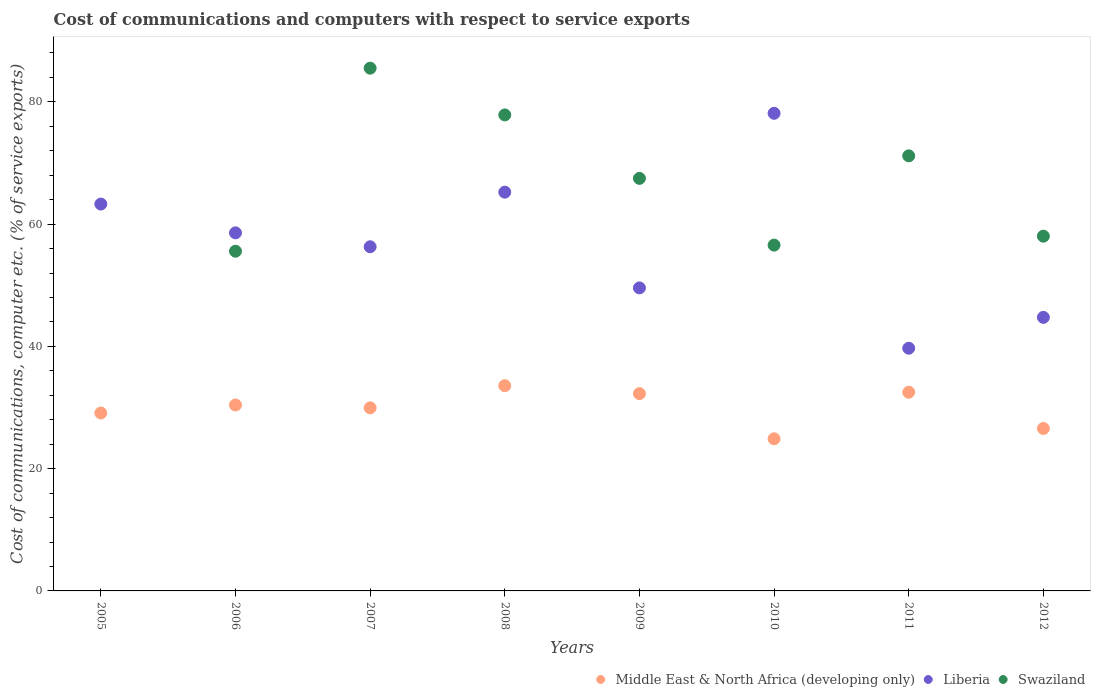How many different coloured dotlines are there?
Offer a terse response. 3. What is the cost of communications and computers in Liberia in 2012?
Offer a very short reply. 44.75. Across all years, what is the maximum cost of communications and computers in Liberia?
Give a very brief answer. 78.13. Across all years, what is the minimum cost of communications and computers in Swaziland?
Offer a very short reply. 0. What is the total cost of communications and computers in Middle East & North Africa (developing only) in the graph?
Provide a short and direct response. 239.25. What is the difference between the cost of communications and computers in Liberia in 2008 and that in 2012?
Provide a succinct answer. 20.48. What is the difference between the cost of communications and computers in Middle East & North Africa (developing only) in 2006 and the cost of communications and computers in Liberia in 2010?
Offer a terse response. -47.72. What is the average cost of communications and computers in Middle East & North Africa (developing only) per year?
Provide a short and direct response. 29.91. In the year 2009, what is the difference between the cost of communications and computers in Middle East & North Africa (developing only) and cost of communications and computers in Liberia?
Provide a short and direct response. -17.3. What is the ratio of the cost of communications and computers in Swaziland in 2008 to that in 2012?
Give a very brief answer. 1.34. Is the difference between the cost of communications and computers in Middle East & North Africa (developing only) in 2005 and 2011 greater than the difference between the cost of communications and computers in Liberia in 2005 and 2011?
Provide a short and direct response. No. What is the difference between the highest and the second highest cost of communications and computers in Middle East & North Africa (developing only)?
Your answer should be compact. 1.07. What is the difference between the highest and the lowest cost of communications and computers in Middle East & North Africa (developing only)?
Your answer should be compact. 8.69. Is it the case that in every year, the sum of the cost of communications and computers in Swaziland and cost of communications and computers in Middle East & North Africa (developing only)  is greater than the cost of communications and computers in Liberia?
Your answer should be very brief. No. Does the cost of communications and computers in Liberia monotonically increase over the years?
Give a very brief answer. No. Is the cost of communications and computers in Swaziland strictly less than the cost of communications and computers in Liberia over the years?
Keep it short and to the point. No. How many dotlines are there?
Make the answer very short. 3. How many years are there in the graph?
Offer a terse response. 8. What is the difference between two consecutive major ticks on the Y-axis?
Your response must be concise. 20. Where does the legend appear in the graph?
Provide a short and direct response. Bottom right. How many legend labels are there?
Make the answer very short. 3. How are the legend labels stacked?
Your response must be concise. Horizontal. What is the title of the graph?
Offer a very short reply. Cost of communications and computers with respect to service exports. Does "Bosnia and Herzegovina" appear as one of the legend labels in the graph?
Provide a succinct answer. No. What is the label or title of the Y-axis?
Give a very brief answer. Cost of communications, computer etc. (% of service exports). What is the Cost of communications, computer etc. (% of service exports) in Middle East & North Africa (developing only) in 2005?
Make the answer very short. 29.1. What is the Cost of communications, computer etc. (% of service exports) of Liberia in 2005?
Keep it short and to the point. 63.28. What is the Cost of communications, computer etc. (% of service exports) of Middle East & North Africa (developing only) in 2006?
Ensure brevity in your answer.  30.41. What is the Cost of communications, computer etc. (% of service exports) of Liberia in 2006?
Offer a terse response. 58.57. What is the Cost of communications, computer etc. (% of service exports) in Swaziland in 2006?
Make the answer very short. 55.57. What is the Cost of communications, computer etc. (% of service exports) in Middle East & North Africa (developing only) in 2007?
Offer a very short reply. 29.94. What is the Cost of communications, computer etc. (% of service exports) in Liberia in 2007?
Provide a succinct answer. 56.29. What is the Cost of communications, computer etc. (% of service exports) in Swaziland in 2007?
Offer a terse response. 85.51. What is the Cost of communications, computer etc. (% of service exports) in Middle East & North Africa (developing only) in 2008?
Ensure brevity in your answer.  33.57. What is the Cost of communications, computer etc. (% of service exports) in Liberia in 2008?
Ensure brevity in your answer.  65.23. What is the Cost of communications, computer etc. (% of service exports) of Swaziland in 2008?
Keep it short and to the point. 77.86. What is the Cost of communications, computer etc. (% of service exports) in Middle East & North Africa (developing only) in 2009?
Provide a succinct answer. 32.27. What is the Cost of communications, computer etc. (% of service exports) in Liberia in 2009?
Provide a succinct answer. 49.57. What is the Cost of communications, computer etc. (% of service exports) in Swaziland in 2009?
Your response must be concise. 67.48. What is the Cost of communications, computer etc. (% of service exports) of Middle East & North Africa (developing only) in 2010?
Offer a very short reply. 24.88. What is the Cost of communications, computer etc. (% of service exports) in Liberia in 2010?
Ensure brevity in your answer.  78.13. What is the Cost of communications, computer etc. (% of service exports) of Swaziland in 2010?
Give a very brief answer. 56.56. What is the Cost of communications, computer etc. (% of service exports) in Middle East & North Africa (developing only) in 2011?
Your answer should be very brief. 32.5. What is the Cost of communications, computer etc. (% of service exports) of Liberia in 2011?
Keep it short and to the point. 39.7. What is the Cost of communications, computer etc. (% of service exports) in Swaziland in 2011?
Provide a succinct answer. 71.17. What is the Cost of communications, computer etc. (% of service exports) in Middle East & North Africa (developing only) in 2012?
Your answer should be very brief. 26.57. What is the Cost of communications, computer etc. (% of service exports) in Liberia in 2012?
Provide a short and direct response. 44.75. What is the Cost of communications, computer etc. (% of service exports) of Swaziland in 2012?
Give a very brief answer. 58.03. Across all years, what is the maximum Cost of communications, computer etc. (% of service exports) of Middle East & North Africa (developing only)?
Provide a succinct answer. 33.57. Across all years, what is the maximum Cost of communications, computer etc. (% of service exports) of Liberia?
Offer a terse response. 78.13. Across all years, what is the maximum Cost of communications, computer etc. (% of service exports) in Swaziland?
Give a very brief answer. 85.51. Across all years, what is the minimum Cost of communications, computer etc. (% of service exports) in Middle East & North Africa (developing only)?
Offer a very short reply. 24.88. Across all years, what is the minimum Cost of communications, computer etc. (% of service exports) in Liberia?
Your response must be concise. 39.7. What is the total Cost of communications, computer etc. (% of service exports) in Middle East & North Africa (developing only) in the graph?
Make the answer very short. 239.25. What is the total Cost of communications, computer etc. (% of service exports) in Liberia in the graph?
Offer a terse response. 455.51. What is the total Cost of communications, computer etc. (% of service exports) of Swaziland in the graph?
Your answer should be compact. 472.18. What is the difference between the Cost of communications, computer etc. (% of service exports) of Middle East & North Africa (developing only) in 2005 and that in 2006?
Your answer should be very brief. -1.31. What is the difference between the Cost of communications, computer etc. (% of service exports) in Liberia in 2005 and that in 2006?
Offer a terse response. 4.71. What is the difference between the Cost of communications, computer etc. (% of service exports) of Middle East & North Africa (developing only) in 2005 and that in 2007?
Give a very brief answer. -0.84. What is the difference between the Cost of communications, computer etc. (% of service exports) in Liberia in 2005 and that in 2007?
Keep it short and to the point. 6.99. What is the difference between the Cost of communications, computer etc. (% of service exports) in Middle East & North Africa (developing only) in 2005 and that in 2008?
Make the answer very short. -4.47. What is the difference between the Cost of communications, computer etc. (% of service exports) in Liberia in 2005 and that in 2008?
Offer a terse response. -1.94. What is the difference between the Cost of communications, computer etc. (% of service exports) of Middle East & North Africa (developing only) in 2005 and that in 2009?
Make the answer very short. -3.17. What is the difference between the Cost of communications, computer etc. (% of service exports) in Liberia in 2005 and that in 2009?
Offer a very short reply. 13.71. What is the difference between the Cost of communications, computer etc. (% of service exports) in Middle East & North Africa (developing only) in 2005 and that in 2010?
Provide a succinct answer. 4.22. What is the difference between the Cost of communications, computer etc. (% of service exports) in Liberia in 2005 and that in 2010?
Provide a short and direct response. -14.84. What is the difference between the Cost of communications, computer etc. (% of service exports) in Middle East & North Africa (developing only) in 2005 and that in 2011?
Offer a terse response. -3.4. What is the difference between the Cost of communications, computer etc. (% of service exports) of Liberia in 2005 and that in 2011?
Provide a short and direct response. 23.58. What is the difference between the Cost of communications, computer etc. (% of service exports) of Middle East & North Africa (developing only) in 2005 and that in 2012?
Ensure brevity in your answer.  2.53. What is the difference between the Cost of communications, computer etc. (% of service exports) in Liberia in 2005 and that in 2012?
Make the answer very short. 18.53. What is the difference between the Cost of communications, computer etc. (% of service exports) of Middle East & North Africa (developing only) in 2006 and that in 2007?
Your answer should be compact. 0.47. What is the difference between the Cost of communications, computer etc. (% of service exports) in Liberia in 2006 and that in 2007?
Provide a succinct answer. 2.28. What is the difference between the Cost of communications, computer etc. (% of service exports) of Swaziland in 2006 and that in 2007?
Make the answer very short. -29.94. What is the difference between the Cost of communications, computer etc. (% of service exports) of Middle East & North Africa (developing only) in 2006 and that in 2008?
Your response must be concise. -3.16. What is the difference between the Cost of communications, computer etc. (% of service exports) of Liberia in 2006 and that in 2008?
Give a very brief answer. -6.66. What is the difference between the Cost of communications, computer etc. (% of service exports) in Swaziland in 2006 and that in 2008?
Keep it short and to the point. -22.29. What is the difference between the Cost of communications, computer etc. (% of service exports) of Middle East & North Africa (developing only) in 2006 and that in 2009?
Provide a short and direct response. -1.86. What is the difference between the Cost of communications, computer etc. (% of service exports) of Liberia in 2006 and that in 2009?
Keep it short and to the point. 9. What is the difference between the Cost of communications, computer etc. (% of service exports) in Swaziland in 2006 and that in 2009?
Give a very brief answer. -11.91. What is the difference between the Cost of communications, computer etc. (% of service exports) of Middle East & North Africa (developing only) in 2006 and that in 2010?
Make the answer very short. 5.53. What is the difference between the Cost of communications, computer etc. (% of service exports) in Liberia in 2006 and that in 2010?
Offer a very short reply. -19.56. What is the difference between the Cost of communications, computer etc. (% of service exports) of Swaziland in 2006 and that in 2010?
Your answer should be compact. -0.99. What is the difference between the Cost of communications, computer etc. (% of service exports) of Middle East & North Africa (developing only) in 2006 and that in 2011?
Make the answer very short. -2.09. What is the difference between the Cost of communications, computer etc. (% of service exports) in Liberia in 2006 and that in 2011?
Your response must be concise. 18.87. What is the difference between the Cost of communications, computer etc. (% of service exports) in Swaziland in 2006 and that in 2011?
Keep it short and to the point. -15.6. What is the difference between the Cost of communications, computer etc. (% of service exports) of Middle East & North Africa (developing only) in 2006 and that in 2012?
Your answer should be compact. 3.84. What is the difference between the Cost of communications, computer etc. (% of service exports) in Liberia in 2006 and that in 2012?
Your answer should be very brief. 13.82. What is the difference between the Cost of communications, computer etc. (% of service exports) of Swaziland in 2006 and that in 2012?
Make the answer very short. -2.46. What is the difference between the Cost of communications, computer etc. (% of service exports) of Middle East & North Africa (developing only) in 2007 and that in 2008?
Provide a succinct answer. -3.63. What is the difference between the Cost of communications, computer etc. (% of service exports) in Liberia in 2007 and that in 2008?
Ensure brevity in your answer.  -8.93. What is the difference between the Cost of communications, computer etc. (% of service exports) in Swaziland in 2007 and that in 2008?
Your answer should be very brief. 7.65. What is the difference between the Cost of communications, computer etc. (% of service exports) of Middle East & North Africa (developing only) in 2007 and that in 2009?
Ensure brevity in your answer.  -2.33. What is the difference between the Cost of communications, computer etc. (% of service exports) of Liberia in 2007 and that in 2009?
Your answer should be compact. 6.73. What is the difference between the Cost of communications, computer etc. (% of service exports) of Swaziland in 2007 and that in 2009?
Ensure brevity in your answer.  18.03. What is the difference between the Cost of communications, computer etc. (% of service exports) in Middle East & North Africa (developing only) in 2007 and that in 2010?
Ensure brevity in your answer.  5.06. What is the difference between the Cost of communications, computer etc. (% of service exports) of Liberia in 2007 and that in 2010?
Make the answer very short. -21.83. What is the difference between the Cost of communications, computer etc. (% of service exports) in Swaziland in 2007 and that in 2010?
Make the answer very short. 28.94. What is the difference between the Cost of communications, computer etc. (% of service exports) in Middle East & North Africa (developing only) in 2007 and that in 2011?
Provide a succinct answer. -2.56. What is the difference between the Cost of communications, computer etc. (% of service exports) of Liberia in 2007 and that in 2011?
Make the answer very short. 16.59. What is the difference between the Cost of communications, computer etc. (% of service exports) in Swaziland in 2007 and that in 2011?
Provide a short and direct response. 14.34. What is the difference between the Cost of communications, computer etc. (% of service exports) in Middle East & North Africa (developing only) in 2007 and that in 2012?
Provide a short and direct response. 3.37. What is the difference between the Cost of communications, computer etc. (% of service exports) of Liberia in 2007 and that in 2012?
Offer a very short reply. 11.55. What is the difference between the Cost of communications, computer etc. (% of service exports) in Swaziland in 2007 and that in 2012?
Keep it short and to the point. 27.48. What is the difference between the Cost of communications, computer etc. (% of service exports) in Liberia in 2008 and that in 2009?
Keep it short and to the point. 15.66. What is the difference between the Cost of communications, computer etc. (% of service exports) of Swaziland in 2008 and that in 2009?
Offer a very short reply. 10.38. What is the difference between the Cost of communications, computer etc. (% of service exports) of Middle East & North Africa (developing only) in 2008 and that in 2010?
Ensure brevity in your answer.  8.69. What is the difference between the Cost of communications, computer etc. (% of service exports) of Liberia in 2008 and that in 2010?
Give a very brief answer. -12.9. What is the difference between the Cost of communications, computer etc. (% of service exports) in Swaziland in 2008 and that in 2010?
Ensure brevity in your answer.  21.3. What is the difference between the Cost of communications, computer etc. (% of service exports) of Middle East & North Africa (developing only) in 2008 and that in 2011?
Make the answer very short. 1.07. What is the difference between the Cost of communications, computer etc. (% of service exports) of Liberia in 2008 and that in 2011?
Your answer should be compact. 25.53. What is the difference between the Cost of communications, computer etc. (% of service exports) in Swaziland in 2008 and that in 2011?
Make the answer very short. 6.69. What is the difference between the Cost of communications, computer etc. (% of service exports) of Middle East & North Africa (developing only) in 2008 and that in 2012?
Provide a succinct answer. 7. What is the difference between the Cost of communications, computer etc. (% of service exports) of Liberia in 2008 and that in 2012?
Offer a terse response. 20.48. What is the difference between the Cost of communications, computer etc. (% of service exports) of Swaziland in 2008 and that in 2012?
Offer a terse response. 19.83. What is the difference between the Cost of communications, computer etc. (% of service exports) in Middle East & North Africa (developing only) in 2009 and that in 2010?
Make the answer very short. 7.39. What is the difference between the Cost of communications, computer etc. (% of service exports) in Liberia in 2009 and that in 2010?
Your answer should be compact. -28.56. What is the difference between the Cost of communications, computer etc. (% of service exports) in Swaziland in 2009 and that in 2010?
Provide a short and direct response. 10.92. What is the difference between the Cost of communications, computer etc. (% of service exports) in Middle East & North Africa (developing only) in 2009 and that in 2011?
Your answer should be compact. -0.23. What is the difference between the Cost of communications, computer etc. (% of service exports) of Liberia in 2009 and that in 2011?
Keep it short and to the point. 9.87. What is the difference between the Cost of communications, computer etc. (% of service exports) of Swaziland in 2009 and that in 2011?
Give a very brief answer. -3.68. What is the difference between the Cost of communications, computer etc. (% of service exports) of Middle East & North Africa (developing only) in 2009 and that in 2012?
Give a very brief answer. 5.7. What is the difference between the Cost of communications, computer etc. (% of service exports) in Liberia in 2009 and that in 2012?
Give a very brief answer. 4.82. What is the difference between the Cost of communications, computer etc. (% of service exports) of Swaziland in 2009 and that in 2012?
Your answer should be very brief. 9.46. What is the difference between the Cost of communications, computer etc. (% of service exports) in Middle East & North Africa (developing only) in 2010 and that in 2011?
Your answer should be compact. -7.62. What is the difference between the Cost of communications, computer etc. (% of service exports) of Liberia in 2010 and that in 2011?
Provide a succinct answer. 38.43. What is the difference between the Cost of communications, computer etc. (% of service exports) in Swaziland in 2010 and that in 2011?
Provide a short and direct response. -14.6. What is the difference between the Cost of communications, computer etc. (% of service exports) in Middle East & North Africa (developing only) in 2010 and that in 2012?
Your response must be concise. -1.69. What is the difference between the Cost of communications, computer etc. (% of service exports) of Liberia in 2010 and that in 2012?
Give a very brief answer. 33.38. What is the difference between the Cost of communications, computer etc. (% of service exports) of Swaziland in 2010 and that in 2012?
Give a very brief answer. -1.46. What is the difference between the Cost of communications, computer etc. (% of service exports) of Middle East & North Africa (developing only) in 2011 and that in 2012?
Your answer should be very brief. 5.93. What is the difference between the Cost of communications, computer etc. (% of service exports) in Liberia in 2011 and that in 2012?
Give a very brief answer. -5.05. What is the difference between the Cost of communications, computer etc. (% of service exports) of Swaziland in 2011 and that in 2012?
Give a very brief answer. 13.14. What is the difference between the Cost of communications, computer etc. (% of service exports) in Middle East & North Africa (developing only) in 2005 and the Cost of communications, computer etc. (% of service exports) in Liberia in 2006?
Make the answer very short. -29.47. What is the difference between the Cost of communications, computer etc. (% of service exports) of Middle East & North Africa (developing only) in 2005 and the Cost of communications, computer etc. (% of service exports) of Swaziland in 2006?
Offer a very short reply. -26.47. What is the difference between the Cost of communications, computer etc. (% of service exports) of Liberia in 2005 and the Cost of communications, computer etc. (% of service exports) of Swaziland in 2006?
Make the answer very short. 7.71. What is the difference between the Cost of communications, computer etc. (% of service exports) in Middle East & North Africa (developing only) in 2005 and the Cost of communications, computer etc. (% of service exports) in Liberia in 2007?
Provide a short and direct response. -27.19. What is the difference between the Cost of communications, computer etc. (% of service exports) of Middle East & North Africa (developing only) in 2005 and the Cost of communications, computer etc. (% of service exports) of Swaziland in 2007?
Offer a terse response. -56.41. What is the difference between the Cost of communications, computer etc. (% of service exports) in Liberia in 2005 and the Cost of communications, computer etc. (% of service exports) in Swaziland in 2007?
Offer a very short reply. -22.23. What is the difference between the Cost of communications, computer etc. (% of service exports) of Middle East & North Africa (developing only) in 2005 and the Cost of communications, computer etc. (% of service exports) of Liberia in 2008?
Your answer should be very brief. -36.12. What is the difference between the Cost of communications, computer etc. (% of service exports) in Middle East & North Africa (developing only) in 2005 and the Cost of communications, computer etc. (% of service exports) in Swaziland in 2008?
Provide a succinct answer. -48.76. What is the difference between the Cost of communications, computer etc. (% of service exports) of Liberia in 2005 and the Cost of communications, computer etc. (% of service exports) of Swaziland in 2008?
Your answer should be very brief. -14.58. What is the difference between the Cost of communications, computer etc. (% of service exports) in Middle East & North Africa (developing only) in 2005 and the Cost of communications, computer etc. (% of service exports) in Liberia in 2009?
Your answer should be compact. -20.47. What is the difference between the Cost of communications, computer etc. (% of service exports) of Middle East & North Africa (developing only) in 2005 and the Cost of communications, computer etc. (% of service exports) of Swaziland in 2009?
Keep it short and to the point. -38.38. What is the difference between the Cost of communications, computer etc. (% of service exports) of Liberia in 2005 and the Cost of communications, computer etc. (% of service exports) of Swaziland in 2009?
Provide a short and direct response. -4.2. What is the difference between the Cost of communications, computer etc. (% of service exports) in Middle East & North Africa (developing only) in 2005 and the Cost of communications, computer etc. (% of service exports) in Liberia in 2010?
Keep it short and to the point. -49.03. What is the difference between the Cost of communications, computer etc. (% of service exports) in Middle East & North Africa (developing only) in 2005 and the Cost of communications, computer etc. (% of service exports) in Swaziland in 2010?
Your response must be concise. -27.46. What is the difference between the Cost of communications, computer etc. (% of service exports) of Liberia in 2005 and the Cost of communications, computer etc. (% of service exports) of Swaziland in 2010?
Give a very brief answer. 6.72. What is the difference between the Cost of communications, computer etc. (% of service exports) of Middle East & North Africa (developing only) in 2005 and the Cost of communications, computer etc. (% of service exports) of Liberia in 2011?
Give a very brief answer. -10.6. What is the difference between the Cost of communications, computer etc. (% of service exports) in Middle East & North Africa (developing only) in 2005 and the Cost of communications, computer etc. (% of service exports) in Swaziland in 2011?
Your answer should be compact. -42.07. What is the difference between the Cost of communications, computer etc. (% of service exports) in Liberia in 2005 and the Cost of communications, computer etc. (% of service exports) in Swaziland in 2011?
Give a very brief answer. -7.89. What is the difference between the Cost of communications, computer etc. (% of service exports) of Middle East & North Africa (developing only) in 2005 and the Cost of communications, computer etc. (% of service exports) of Liberia in 2012?
Provide a succinct answer. -15.65. What is the difference between the Cost of communications, computer etc. (% of service exports) of Middle East & North Africa (developing only) in 2005 and the Cost of communications, computer etc. (% of service exports) of Swaziland in 2012?
Your response must be concise. -28.93. What is the difference between the Cost of communications, computer etc. (% of service exports) in Liberia in 2005 and the Cost of communications, computer etc. (% of service exports) in Swaziland in 2012?
Ensure brevity in your answer.  5.26. What is the difference between the Cost of communications, computer etc. (% of service exports) in Middle East & North Africa (developing only) in 2006 and the Cost of communications, computer etc. (% of service exports) in Liberia in 2007?
Provide a succinct answer. -25.88. What is the difference between the Cost of communications, computer etc. (% of service exports) in Middle East & North Africa (developing only) in 2006 and the Cost of communications, computer etc. (% of service exports) in Swaziland in 2007?
Provide a short and direct response. -55.1. What is the difference between the Cost of communications, computer etc. (% of service exports) in Liberia in 2006 and the Cost of communications, computer etc. (% of service exports) in Swaziland in 2007?
Offer a very short reply. -26.94. What is the difference between the Cost of communications, computer etc. (% of service exports) in Middle East & North Africa (developing only) in 2006 and the Cost of communications, computer etc. (% of service exports) in Liberia in 2008?
Ensure brevity in your answer.  -34.81. What is the difference between the Cost of communications, computer etc. (% of service exports) of Middle East & North Africa (developing only) in 2006 and the Cost of communications, computer etc. (% of service exports) of Swaziland in 2008?
Keep it short and to the point. -47.45. What is the difference between the Cost of communications, computer etc. (% of service exports) in Liberia in 2006 and the Cost of communications, computer etc. (% of service exports) in Swaziland in 2008?
Your answer should be compact. -19.29. What is the difference between the Cost of communications, computer etc. (% of service exports) in Middle East & North Africa (developing only) in 2006 and the Cost of communications, computer etc. (% of service exports) in Liberia in 2009?
Offer a very short reply. -19.16. What is the difference between the Cost of communications, computer etc. (% of service exports) in Middle East & North Africa (developing only) in 2006 and the Cost of communications, computer etc. (% of service exports) in Swaziland in 2009?
Offer a terse response. -37.07. What is the difference between the Cost of communications, computer etc. (% of service exports) in Liberia in 2006 and the Cost of communications, computer etc. (% of service exports) in Swaziland in 2009?
Your answer should be compact. -8.91. What is the difference between the Cost of communications, computer etc. (% of service exports) of Middle East & North Africa (developing only) in 2006 and the Cost of communications, computer etc. (% of service exports) of Liberia in 2010?
Your answer should be very brief. -47.72. What is the difference between the Cost of communications, computer etc. (% of service exports) in Middle East & North Africa (developing only) in 2006 and the Cost of communications, computer etc. (% of service exports) in Swaziland in 2010?
Offer a terse response. -26.15. What is the difference between the Cost of communications, computer etc. (% of service exports) of Liberia in 2006 and the Cost of communications, computer etc. (% of service exports) of Swaziland in 2010?
Give a very brief answer. 2.01. What is the difference between the Cost of communications, computer etc. (% of service exports) in Middle East & North Africa (developing only) in 2006 and the Cost of communications, computer etc. (% of service exports) in Liberia in 2011?
Your answer should be compact. -9.29. What is the difference between the Cost of communications, computer etc. (% of service exports) of Middle East & North Africa (developing only) in 2006 and the Cost of communications, computer etc. (% of service exports) of Swaziland in 2011?
Your response must be concise. -40.76. What is the difference between the Cost of communications, computer etc. (% of service exports) of Liberia in 2006 and the Cost of communications, computer etc. (% of service exports) of Swaziland in 2011?
Provide a succinct answer. -12.6. What is the difference between the Cost of communications, computer etc. (% of service exports) in Middle East & North Africa (developing only) in 2006 and the Cost of communications, computer etc. (% of service exports) in Liberia in 2012?
Offer a terse response. -14.34. What is the difference between the Cost of communications, computer etc. (% of service exports) in Middle East & North Africa (developing only) in 2006 and the Cost of communications, computer etc. (% of service exports) in Swaziland in 2012?
Provide a short and direct response. -27.62. What is the difference between the Cost of communications, computer etc. (% of service exports) of Liberia in 2006 and the Cost of communications, computer etc. (% of service exports) of Swaziland in 2012?
Make the answer very short. 0.54. What is the difference between the Cost of communications, computer etc. (% of service exports) in Middle East & North Africa (developing only) in 2007 and the Cost of communications, computer etc. (% of service exports) in Liberia in 2008?
Provide a short and direct response. -35.28. What is the difference between the Cost of communications, computer etc. (% of service exports) in Middle East & North Africa (developing only) in 2007 and the Cost of communications, computer etc. (% of service exports) in Swaziland in 2008?
Provide a succinct answer. -47.91. What is the difference between the Cost of communications, computer etc. (% of service exports) of Liberia in 2007 and the Cost of communications, computer etc. (% of service exports) of Swaziland in 2008?
Provide a succinct answer. -21.57. What is the difference between the Cost of communications, computer etc. (% of service exports) in Middle East & North Africa (developing only) in 2007 and the Cost of communications, computer etc. (% of service exports) in Liberia in 2009?
Offer a very short reply. -19.62. What is the difference between the Cost of communications, computer etc. (% of service exports) in Middle East & North Africa (developing only) in 2007 and the Cost of communications, computer etc. (% of service exports) in Swaziland in 2009?
Provide a short and direct response. -37.54. What is the difference between the Cost of communications, computer etc. (% of service exports) in Liberia in 2007 and the Cost of communications, computer etc. (% of service exports) in Swaziland in 2009?
Keep it short and to the point. -11.19. What is the difference between the Cost of communications, computer etc. (% of service exports) of Middle East & North Africa (developing only) in 2007 and the Cost of communications, computer etc. (% of service exports) of Liberia in 2010?
Your answer should be compact. -48.18. What is the difference between the Cost of communications, computer etc. (% of service exports) of Middle East & North Africa (developing only) in 2007 and the Cost of communications, computer etc. (% of service exports) of Swaziland in 2010?
Your response must be concise. -26.62. What is the difference between the Cost of communications, computer etc. (% of service exports) in Liberia in 2007 and the Cost of communications, computer etc. (% of service exports) in Swaziland in 2010?
Give a very brief answer. -0.27. What is the difference between the Cost of communications, computer etc. (% of service exports) in Middle East & North Africa (developing only) in 2007 and the Cost of communications, computer etc. (% of service exports) in Liberia in 2011?
Keep it short and to the point. -9.76. What is the difference between the Cost of communications, computer etc. (% of service exports) in Middle East & North Africa (developing only) in 2007 and the Cost of communications, computer etc. (% of service exports) in Swaziland in 2011?
Make the answer very short. -41.22. What is the difference between the Cost of communications, computer etc. (% of service exports) in Liberia in 2007 and the Cost of communications, computer etc. (% of service exports) in Swaziland in 2011?
Give a very brief answer. -14.87. What is the difference between the Cost of communications, computer etc. (% of service exports) in Middle East & North Africa (developing only) in 2007 and the Cost of communications, computer etc. (% of service exports) in Liberia in 2012?
Your answer should be compact. -14.8. What is the difference between the Cost of communications, computer etc. (% of service exports) of Middle East & North Africa (developing only) in 2007 and the Cost of communications, computer etc. (% of service exports) of Swaziland in 2012?
Offer a terse response. -28.08. What is the difference between the Cost of communications, computer etc. (% of service exports) of Liberia in 2007 and the Cost of communications, computer etc. (% of service exports) of Swaziland in 2012?
Ensure brevity in your answer.  -1.73. What is the difference between the Cost of communications, computer etc. (% of service exports) of Middle East & North Africa (developing only) in 2008 and the Cost of communications, computer etc. (% of service exports) of Liberia in 2009?
Your answer should be compact. -16. What is the difference between the Cost of communications, computer etc. (% of service exports) in Middle East & North Africa (developing only) in 2008 and the Cost of communications, computer etc. (% of service exports) in Swaziland in 2009?
Keep it short and to the point. -33.91. What is the difference between the Cost of communications, computer etc. (% of service exports) in Liberia in 2008 and the Cost of communications, computer etc. (% of service exports) in Swaziland in 2009?
Offer a very short reply. -2.26. What is the difference between the Cost of communications, computer etc. (% of service exports) in Middle East & North Africa (developing only) in 2008 and the Cost of communications, computer etc. (% of service exports) in Liberia in 2010?
Offer a terse response. -44.55. What is the difference between the Cost of communications, computer etc. (% of service exports) in Middle East & North Africa (developing only) in 2008 and the Cost of communications, computer etc. (% of service exports) in Swaziland in 2010?
Offer a very short reply. -22.99. What is the difference between the Cost of communications, computer etc. (% of service exports) of Liberia in 2008 and the Cost of communications, computer etc. (% of service exports) of Swaziland in 2010?
Provide a short and direct response. 8.66. What is the difference between the Cost of communications, computer etc. (% of service exports) in Middle East & North Africa (developing only) in 2008 and the Cost of communications, computer etc. (% of service exports) in Liberia in 2011?
Your answer should be very brief. -6.13. What is the difference between the Cost of communications, computer etc. (% of service exports) of Middle East & North Africa (developing only) in 2008 and the Cost of communications, computer etc. (% of service exports) of Swaziland in 2011?
Make the answer very short. -37.59. What is the difference between the Cost of communications, computer etc. (% of service exports) in Liberia in 2008 and the Cost of communications, computer etc. (% of service exports) in Swaziland in 2011?
Offer a very short reply. -5.94. What is the difference between the Cost of communications, computer etc. (% of service exports) in Middle East & North Africa (developing only) in 2008 and the Cost of communications, computer etc. (% of service exports) in Liberia in 2012?
Provide a short and direct response. -11.18. What is the difference between the Cost of communications, computer etc. (% of service exports) of Middle East & North Africa (developing only) in 2008 and the Cost of communications, computer etc. (% of service exports) of Swaziland in 2012?
Your answer should be compact. -24.45. What is the difference between the Cost of communications, computer etc. (% of service exports) of Liberia in 2008 and the Cost of communications, computer etc. (% of service exports) of Swaziland in 2012?
Keep it short and to the point. 7.2. What is the difference between the Cost of communications, computer etc. (% of service exports) of Middle East & North Africa (developing only) in 2009 and the Cost of communications, computer etc. (% of service exports) of Liberia in 2010?
Provide a succinct answer. -45.85. What is the difference between the Cost of communications, computer etc. (% of service exports) of Middle East & North Africa (developing only) in 2009 and the Cost of communications, computer etc. (% of service exports) of Swaziland in 2010?
Ensure brevity in your answer.  -24.29. What is the difference between the Cost of communications, computer etc. (% of service exports) in Liberia in 2009 and the Cost of communications, computer etc. (% of service exports) in Swaziland in 2010?
Your response must be concise. -7. What is the difference between the Cost of communications, computer etc. (% of service exports) of Middle East & North Africa (developing only) in 2009 and the Cost of communications, computer etc. (% of service exports) of Liberia in 2011?
Ensure brevity in your answer.  -7.43. What is the difference between the Cost of communications, computer etc. (% of service exports) of Middle East & North Africa (developing only) in 2009 and the Cost of communications, computer etc. (% of service exports) of Swaziland in 2011?
Offer a terse response. -38.89. What is the difference between the Cost of communications, computer etc. (% of service exports) of Liberia in 2009 and the Cost of communications, computer etc. (% of service exports) of Swaziland in 2011?
Offer a very short reply. -21.6. What is the difference between the Cost of communications, computer etc. (% of service exports) of Middle East & North Africa (developing only) in 2009 and the Cost of communications, computer etc. (% of service exports) of Liberia in 2012?
Ensure brevity in your answer.  -12.48. What is the difference between the Cost of communications, computer etc. (% of service exports) in Middle East & North Africa (developing only) in 2009 and the Cost of communications, computer etc. (% of service exports) in Swaziland in 2012?
Your response must be concise. -25.75. What is the difference between the Cost of communications, computer etc. (% of service exports) of Liberia in 2009 and the Cost of communications, computer etc. (% of service exports) of Swaziland in 2012?
Your answer should be compact. -8.46. What is the difference between the Cost of communications, computer etc. (% of service exports) in Middle East & North Africa (developing only) in 2010 and the Cost of communications, computer etc. (% of service exports) in Liberia in 2011?
Ensure brevity in your answer.  -14.82. What is the difference between the Cost of communications, computer etc. (% of service exports) in Middle East & North Africa (developing only) in 2010 and the Cost of communications, computer etc. (% of service exports) in Swaziland in 2011?
Make the answer very short. -46.28. What is the difference between the Cost of communications, computer etc. (% of service exports) of Liberia in 2010 and the Cost of communications, computer etc. (% of service exports) of Swaziland in 2011?
Offer a terse response. 6.96. What is the difference between the Cost of communications, computer etc. (% of service exports) of Middle East & North Africa (developing only) in 2010 and the Cost of communications, computer etc. (% of service exports) of Liberia in 2012?
Make the answer very short. -19.86. What is the difference between the Cost of communications, computer etc. (% of service exports) of Middle East & North Africa (developing only) in 2010 and the Cost of communications, computer etc. (% of service exports) of Swaziland in 2012?
Give a very brief answer. -33.14. What is the difference between the Cost of communications, computer etc. (% of service exports) in Liberia in 2010 and the Cost of communications, computer etc. (% of service exports) in Swaziland in 2012?
Keep it short and to the point. 20.1. What is the difference between the Cost of communications, computer etc. (% of service exports) in Middle East & North Africa (developing only) in 2011 and the Cost of communications, computer etc. (% of service exports) in Liberia in 2012?
Your response must be concise. -12.25. What is the difference between the Cost of communications, computer etc. (% of service exports) of Middle East & North Africa (developing only) in 2011 and the Cost of communications, computer etc. (% of service exports) of Swaziland in 2012?
Your answer should be very brief. -25.53. What is the difference between the Cost of communications, computer etc. (% of service exports) in Liberia in 2011 and the Cost of communications, computer etc. (% of service exports) in Swaziland in 2012?
Keep it short and to the point. -18.33. What is the average Cost of communications, computer etc. (% of service exports) of Middle East & North Africa (developing only) per year?
Make the answer very short. 29.91. What is the average Cost of communications, computer etc. (% of service exports) in Liberia per year?
Keep it short and to the point. 56.94. What is the average Cost of communications, computer etc. (% of service exports) of Swaziland per year?
Your answer should be compact. 59.02. In the year 2005, what is the difference between the Cost of communications, computer etc. (% of service exports) in Middle East & North Africa (developing only) and Cost of communications, computer etc. (% of service exports) in Liberia?
Provide a short and direct response. -34.18. In the year 2006, what is the difference between the Cost of communications, computer etc. (% of service exports) of Middle East & North Africa (developing only) and Cost of communications, computer etc. (% of service exports) of Liberia?
Offer a terse response. -28.16. In the year 2006, what is the difference between the Cost of communications, computer etc. (% of service exports) of Middle East & North Africa (developing only) and Cost of communications, computer etc. (% of service exports) of Swaziland?
Your response must be concise. -25.16. In the year 2006, what is the difference between the Cost of communications, computer etc. (% of service exports) of Liberia and Cost of communications, computer etc. (% of service exports) of Swaziland?
Your response must be concise. 3. In the year 2007, what is the difference between the Cost of communications, computer etc. (% of service exports) in Middle East & North Africa (developing only) and Cost of communications, computer etc. (% of service exports) in Liberia?
Give a very brief answer. -26.35. In the year 2007, what is the difference between the Cost of communications, computer etc. (% of service exports) of Middle East & North Africa (developing only) and Cost of communications, computer etc. (% of service exports) of Swaziland?
Your answer should be very brief. -55.56. In the year 2007, what is the difference between the Cost of communications, computer etc. (% of service exports) of Liberia and Cost of communications, computer etc. (% of service exports) of Swaziland?
Your answer should be very brief. -29.21. In the year 2008, what is the difference between the Cost of communications, computer etc. (% of service exports) of Middle East & North Africa (developing only) and Cost of communications, computer etc. (% of service exports) of Liberia?
Your answer should be very brief. -31.65. In the year 2008, what is the difference between the Cost of communications, computer etc. (% of service exports) in Middle East & North Africa (developing only) and Cost of communications, computer etc. (% of service exports) in Swaziland?
Your response must be concise. -44.29. In the year 2008, what is the difference between the Cost of communications, computer etc. (% of service exports) in Liberia and Cost of communications, computer etc. (% of service exports) in Swaziland?
Your answer should be very brief. -12.63. In the year 2009, what is the difference between the Cost of communications, computer etc. (% of service exports) of Middle East & North Africa (developing only) and Cost of communications, computer etc. (% of service exports) of Liberia?
Your answer should be compact. -17.3. In the year 2009, what is the difference between the Cost of communications, computer etc. (% of service exports) in Middle East & North Africa (developing only) and Cost of communications, computer etc. (% of service exports) in Swaziland?
Provide a succinct answer. -35.21. In the year 2009, what is the difference between the Cost of communications, computer etc. (% of service exports) of Liberia and Cost of communications, computer etc. (% of service exports) of Swaziland?
Provide a short and direct response. -17.91. In the year 2010, what is the difference between the Cost of communications, computer etc. (% of service exports) of Middle East & North Africa (developing only) and Cost of communications, computer etc. (% of service exports) of Liberia?
Keep it short and to the point. -53.24. In the year 2010, what is the difference between the Cost of communications, computer etc. (% of service exports) of Middle East & North Africa (developing only) and Cost of communications, computer etc. (% of service exports) of Swaziland?
Provide a succinct answer. -31.68. In the year 2010, what is the difference between the Cost of communications, computer etc. (% of service exports) in Liberia and Cost of communications, computer etc. (% of service exports) in Swaziland?
Give a very brief answer. 21.56. In the year 2011, what is the difference between the Cost of communications, computer etc. (% of service exports) of Middle East & North Africa (developing only) and Cost of communications, computer etc. (% of service exports) of Liberia?
Ensure brevity in your answer.  -7.2. In the year 2011, what is the difference between the Cost of communications, computer etc. (% of service exports) of Middle East & North Africa (developing only) and Cost of communications, computer etc. (% of service exports) of Swaziland?
Make the answer very short. -38.67. In the year 2011, what is the difference between the Cost of communications, computer etc. (% of service exports) of Liberia and Cost of communications, computer etc. (% of service exports) of Swaziland?
Make the answer very short. -31.47. In the year 2012, what is the difference between the Cost of communications, computer etc. (% of service exports) of Middle East & North Africa (developing only) and Cost of communications, computer etc. (% of service exports) of Liberia?
Your answer should be compact. -18.18. In the year 2012, what is the difference between the Cost of communications, computer etc. (% of service exports) in Middle East & North Africa (developing only) and Cost of communications, computer etc. (% of service exports) in Swaziland?
Offer a terse response. -31.46. In the year 2012, what is the difference between the Cost of communications, computer etc. (% of service exports) of Liberia and Cost of communications, computer etc. (% of service exports) of Swaziland?
Your response must be concise. -13.28. What is the ratio of the Cost of communications, computer etc. (% of service exports) in Middle East & North Africa (developing only) in 2005 to that in 2006?
Offer a terse response. 0.96. What is the ratio of the Cost of communications, computer etc. (% of service exports) in Liberia in 2005 to that in 2006?
Give a very brief answer. 1.08. What is the ratio of the Cost of communications, computer etc. (% of service exports) of Middle East & North Africa (developing only) in 2005 to that in 2007?
Provide a succinct answer. 0.97. What is the ratio of the Cost of communications, computer etc. (% of service exports) of Liberia in 2005 to that in 2007?
Provide a succinct answer. 1.12. What is the ratio of the Cost of communications, computer etc. (% of service exports) in Middle East & North Africa (developing only) in 2005 to that in 2008?
Your answer should be compact. 0.87. What is the ratio of the Cost of communications, computer etc. (% of service exports) of Liberia in 2005 to that in 2008?
Provide a short and direct response. 0.97. What is the ratio of the Cost of communications, computer etc. (% of service exports) in Middle East & North Africa (developing only) in 2005 to that in 2009?
Ensure brevity in your answer.  0.9. What is the ratio of the Cost of communications, computer etc. (% of service exports) in Liberia in 2005 to that in 2009?
Offer a terse response. 1.28. What is the ratio of the Cost of communications, computer etc. (% of service exports) of Middle East & North Africa (developing only) in 2005 to that in 2010?
Keep it short and to the point. 1.17. What is the ratio of the Cost of communications, computer etc. (% of service exports) of Liberia in 2005 to that in 2010?
Provide a succinct answer. 0.81. What is the ratio of the Cost of communications, computer etc. (% of service exports) in Middle East & North Africa (developing only) in 2005 to that in 2011?
Your answer should be compact. 0.9. What is the ratio of the Cost of communications, computer etc. (% of service exports) in Liberia in 2005 to that in 2011?
Your answer should be very brief. 1.59. What is the ratio of the Cost of communications, computer etc. (% of service exports) in Middle East & North Africa (developing only) in 2005 to that in 2012?
Offer a very short reply. 1.1. What is the ratio of the Cost of communications, computer etc. (% of service exports) of Liberia in 2005 to that in 2012?
Give a very brief answer. 1.41. What is the ratio of the Cost of communications, computer etc. (% of service exports) of Middle East & North Africa (developing only) in 2006 to that in 2007?
Provide a short and direct response. 1.02. What is the ratio of the Cost of communications, computer etc. (% of service exports) in Liberia in 2006 to that in 2007?
Provide a short and direct response. 1.04. What is the ratio of the Cost of communications, computer etc. (% of service exports) in Swaziland in 2006 to that in 2007?
Ensure brevity in your answer.  0.65. What is the ratio of the Cost of communications, computer etc. (% of service exports) in Middle East & North Africa (developing only) in 2006 to that in 2008?
Offer a very short reply. 0.91. What is the ratio of the Cost of communications, computer etc. (% of service exports) of Liberia in 2006 to that in 2008?
Ensure brevity in your answer.  0.9. What is the ratio of the Cost of communications, computer etc. (% of service exports) in Swaziland in 2006 to that in 2008?
Provide a short and direct response. 0.71. What is the ratio of the Cost of communications, computer etc. (% of service exports) in Middle East & North Africa (developing only) in 2006 to that in 2009?
Keep it short and to the point. 0.94. What is the ratio of the Cost of communications, computer etc. (% of service exports) in Liberia in 2006 to that in 2009?
Offer a terse response. 1.18. What is the ratio of the Cost of communications, computer etc. (% of service exports) of Swaziland in 2006 to that in 2009?
Your response must be concise. 0.82. What is the ratio of the Cost of communications, computer etc. (% of service exports) in Middle East & North Africa (developing only) in 2006 to that in 2010?
Your response must be concise. 1.22. What is the ratio of the Cost of communications, computer etc. (% of service exports) of Liberia in 2006 to that in 2010?
Make the answer very short. 0.75. What is the ratio of the Cost of communications, computer etc. (% of service exports) in Swaziland in 2006 to that in 2010?
Ensure brevity in your answer.  0.98. What is the ratio of the Cost of communications, computer etc. (% of service exports) in Middle East & North Africa (developing only) in 2006 to that in 2011?
Your answer should be compact. 0.94. What is the ratio of the Cost of communications, computer etc. (% of service exports) of Liberia in 2006 to that in 2011?
Your response must be concise. 1.48. What is the ratio of the Cost of communications, computer etc. (% of service exports) in Swaziland in 2006 to that in 2011?
Provide a short and direct response. 0.78. What is the ratio of the Cost of communications, computer etc. (% of service exports) of Middle East & North Africa (developing only) in 2006 to that in 2012?
Provide a short and direct response. 1.14. What is the ratio of the Cost of communications, computer etc. (% of service exports) in Liberia in 2006 to that in 2012?
Your answer should be compact. 1.31. What is the ratio of the Cost of communications, computer etc. (% of service exports) of Swaziland in 2006 to that in 2012?
Offer a terse response. 0.96. What is the ratio of the Cost of communications, computer etc. (% of service exports) of Middle East & North Africa (developing only) in 2007 to that in 2008?
Make the answer very short. 0.89. What is the ratio of the Cost of communications, computer etc. (% of service exports) of Liberia in 2007 to that in 2008?
Provide a short and direct response. 0.86. What is the ratio of the Cost of communications, computer etc. (% of service exports) in Swaziland in 2007 to that in 2008?
Your answer should be very brief. 1.1. What is the ratio of the Cost of communications, computer etc. (% of service exports) in Middle East & North Africa (developing only) in 2007 to that in 2009?
Provide a succinct answer. 0.93. What is the ratio of the Cost of communications, computer etc. (% of service exports) in Liberia in 2007 to that in 2009?
Provide a succinct answer. 1.14. What is the ratio of the Cost of communications, computer etc. (% of service exports) in Swaziland in 2007 to that in 2009?
Provide a succinct answer. 1.27. What is the ratio of the Cost of communications, computer etc. (% of service exports) in Middle East & North Africa (developing only) in 2007 to that in 2010?
Provide a succinct answer. 1.2. What is the ratio of the Cost of communications, computer etc. (% of service exports) in Liberia in 2007 to that in 2010?
Your answer should be compact. 0.72. What is the ratio of the Cost of communications, computer etc. (% of service exports) in Swaziland in 2007 to that in 2010?
Make the answer very short. 1.51. What is the ratio of the Cost of communications, computer etc. (% of service exports) of Middle East & North Africa (developing only) in 2007 to that in 2011?
Make the answer very short. 0.92. What is the ratio of the Cost of communications, computer etc. (% of service exports) in Liberia in 2007 to that in 2011?
Your answer should be very brief. 1.42. What is the ratio of the Cost of communications, computer etc. (% of service exports) of Swaziland in 2007 to that in 2011?
Provide a succinct answer. 1.2. What is the ratio of the Cost of communications, computer etc. (% of service exports) of Middle East & North Africa (developing only) in 2007 to that in 2012?
Provide a succinct answer. 1.13. What is the ratio of the Cost of communications, computer etc. (% of service exports) in Liberia in 2007 to that in 2012?
Provide a succinct answer. 1.26. What is the ratio of the Cost of communications, computer etc. (% of service exports) of Swaziland in 2007 to that in 2012?
Your response must be concise. 1.47. What is the ratio of the Cost of communications, computer etc. (% of service exports) of Middle East & North Africa (developing only) in 2008 to that in 2009?
Give a very brief answer. 1.04. What is the ratio of the Cost of communications, computer etc. (% of service exports) of Liberia in 2008 to that in 2009?
Keep it short and to the point. 1.32. What is the ratio of the Cost of communications, computer etc. (% of service exports) of Swaziland in 2008 to that in 2009?
Your answer should be very brief. 1.15. What is the ratio of the Cost of communications, computer etc. (% of service exports) in Middle East & North Africa (developing only) in 2008 to that in 2010?
Your answer should be compact. 1.35. What is the ratio of the Cost of communications, computer etc. (% of service exports) of Liberia in 2008 to that in 2010?
Your response must be concise. 0.83. What is the ratio of the Cost of communications, computer etc. (% of service exports) in Swaziland in 2008 to that in 2010?
Offer a terse response. 1.38. What is the ratio of the Cost of communications, computer etc. (% of service exports) of Middle East & North Africa (developing only) in 2008 to that in 2011?
Keep it short and to the point. 1.03. What is the ratio of the Cost of communications, computer etc. (% of service exports) in Liberia in 2008 to that in 2011?
Make the answer very short. 1.64. What is the ratio of the Cost of communications, computer etc. (% of service exports) of Swaziland in 2008 to that in 2011?
Ensure brevity in your answer.  1.09. What is the ratio of the Cost of communications, computer etc. (% of service exports) in Middle East & North Africa (developing only) in 2008 to that in 2012?
Provide a short and direct response. 1.26. What is the ratio of the Cost of communications, computer etc. (% of service exports) in Liberia in 2008 to that in 2012?
Offer a very short reply. 1.46. What is the ratio of the Cost of communications, computer etc. (% of service exports) in Swaziland in 2008 to that in 2012?
Make the answer very short. 1.34. What is the ratio of the Cost of communications, computer etc. (% of service exports) of Middle East & North Africa (developing only) in 2009 to that in 2010?
Make the answer very short. 1.3. What is the ratio of the Cost of communications, computer etc. (% of service exports) of Liberia in 2009 to that in 2010?
Offer a terse response. 0.63. What is the ratio of the Cost of communications, computer etc. (% of service exports) of Swaziland in 2009 to that in 2010?
Give a very brief answer. 1.19. What is the ratio of the Cost of communications, computer etc. (% of service exports) in Middle East & North Africa (developing only) in 2009 to that in 2011?
Offer a terse response. 0.99. What is the ratio of the Cost of communications, computer etc. (% of service exports) in Liberia in 2009 to that in 2011?
Keep it short and to the point. 1.25. What is the ratio of the Cost of communications, computer etc. (% of service exports) in Swaziland in 2009 to that in 2011?
Offer a very short reply. 0.95. What is the ratio of the Cost of communications, computer etc. (% of service exports) of Middle East & North Africa (developing only) in 2009 to that in 2012?
Your answer should be compact. 1.21. What is the ratio of the Cost of communications, computer etc. (% of service exports) of Liberia in 2009 to that in 2012?
Make the answer very short. 1.11. What is the ratio of the Cost of communications, computer etc. (% of service exports) of Swaziland in 2009 to that in 2012?
Offer a very short reply. 1.16. What is the ratio of the Cost of communications, computer etc. (% of service exports) in Middle East & North Africa (developing only) in 2010 to that in 2011?
Offer a terse response. 0.77. What is the ratio of the Cost of communications, computer etc. (% of service exports) of Liberia in 2010 to that in 2011?
Your answer should be compact. 1.97. What is the ratio of the Cost of communications, computer etc. (% of service exports) in Swaziland in 2010 to that in 2011?
Your answer should be compact. 0.79. What is the ratio of the Cost of communications, computer etc. (% of service exports) of Middle East & North Africa (developing only) in 2010 to that in 2012?
Ensure brevity in your answer.  0.94. What is the ratio of the Cost of communications, computer etc. (% of service exports) in Liberia in 2010 to that in 2012?
Provide a succinct answer. 1.75. What is the ratio of the Cost of communications, computer etc. (% of service exports) of Swaziland in 2010 to that in 2012?
Offer a terse response. 0.97. What is the ratio of the Cost of communications, computer etc. (% of service exports) in Middle East & North Africa (developing only) in 2011 to that in 2012?
Your answer should be compact. 1.22. What is the ratio of the Cost of communications, computer etc. (% of service exports) of Liberia in 2011 to that in 2012?
Give a very brief answer. 0.89. What is the ratio of the Cost of communications, computer etc. (% of service exports) of Swaziland in 2011 to that in 2012?
Your answer should be very brief. 1.23. What is the difference between the highest and the second highest Cost of communications, computer etc. (% of service exports) in Middle East & North Africa (developing only)?
Your answer should be compact. 1.07. What is the difference between the highest and the second highest Cost of communications, computer etc. (% of service exports) in Liberia?
Offer a terse response. 12.9. What is the difference between the highest and the second highest Cost of communications, computer etc. (% of service exports) in Swaziland?
Make the answer very short. 7.65. What is the difference between the highest and the lowest Cost of communications, computer etc. (% of service exports) in Middle East & North Africa (developing only)?
Your response must be concise. 8.69. What is the difference between the highest and the lowest Cost of communications, computer etc. (% of service exports) of Liberia?
Give a very brief answer. 38.43. What is the difference between the highest and the lowest Cost of communications, computer etc. (% of service exports) of Swaziland?
Your answer should be very brief. 85.51. 